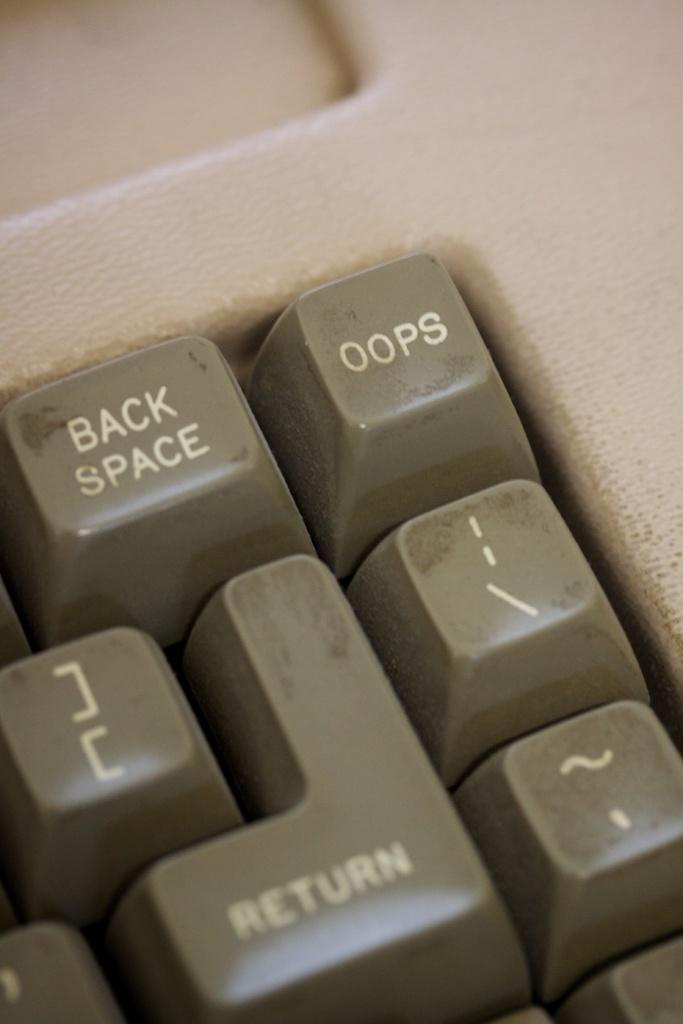Which key do you press to delete?
Your response must be concise. Oops. What key is to the left of oops?
Make the answer very short. Back space. 